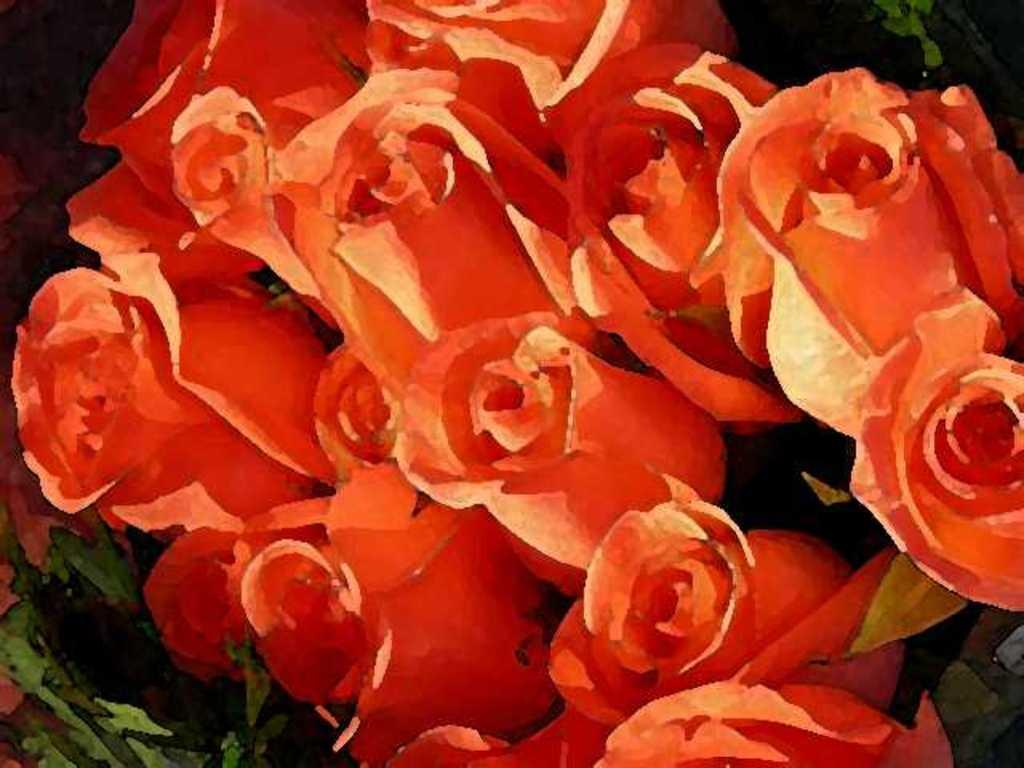What type of flowers are in the image? There is a bunch of roses in the image. What is the condition of the roses in the image? The roses are painted. How many brothers are depicted in the image? There are no brothers present in the image; it features a bunch of painted roses. What type of punishment is being administered in the image? There is no punishment being administered in the image; it features a bunch of painted roses. 